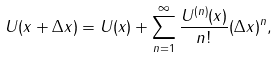<formula> <loc_0><loc_0><loc_500><loc_500>U ( x + \Delta x ) = U ( x ) + \sum _ { n = 1 } ^ { \infty } \frac { U ^ { ( n ) } ( x ) } { n ! } ( \Delta x ) ^ { n } ,</formula> 